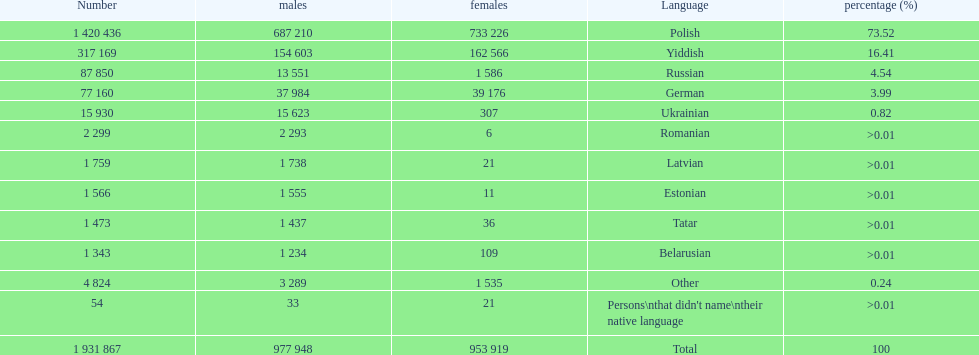What was the next most commonly spoken language in poland after russian? German. 